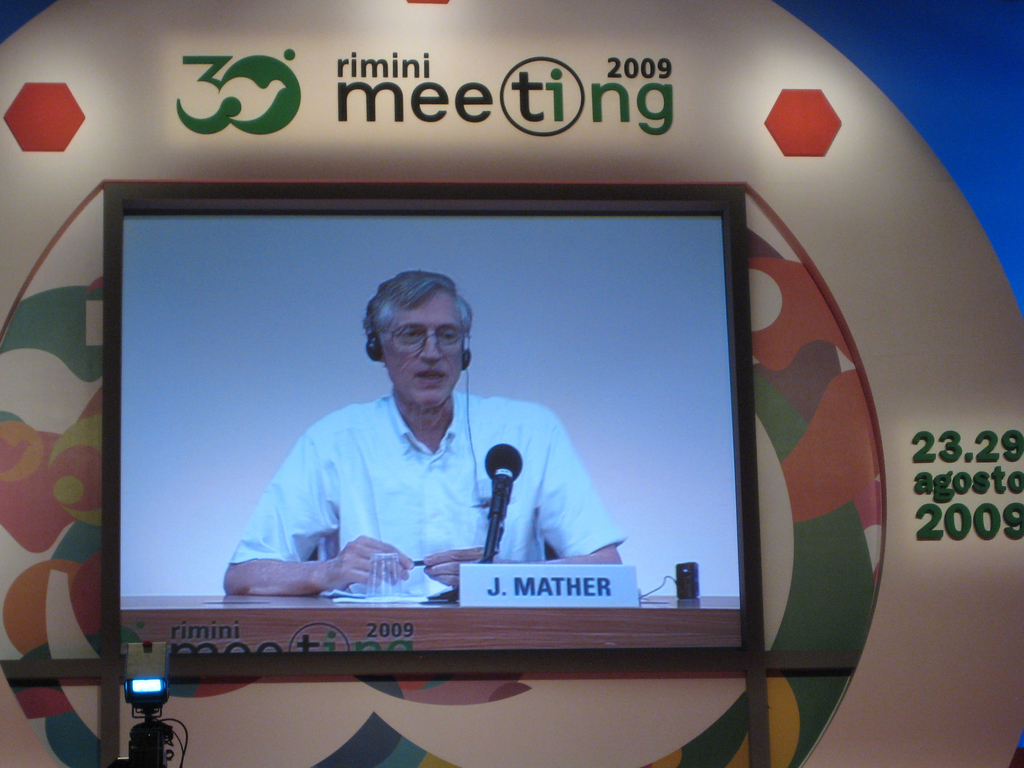Who is J. Mather and why was he speaking at the Rimini Meeting in 2009? J. Mather is a renowned physicist known for his work in astrophysics. He was speaking at the Rimini Meeting in 2009 to discuss recent advancements in scientific understanding and their relevance to global issues, sharing insights from his experiences and research. What are the general themes or topics covered during the Rimini Meeting events? The Rimini Meeting typically covers a wide array of subjects including politics, economics, faith, and culture, aiming to foster dialogue and understanding among different sectors of society, with a strong emphasis on the interplay between science and human values. 